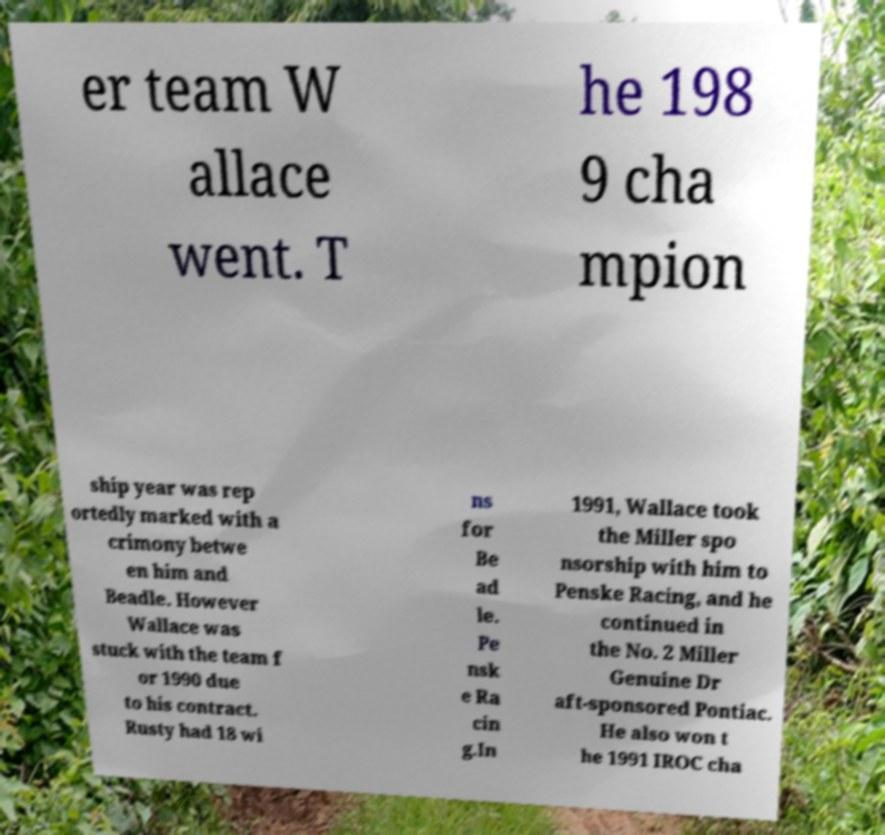Please identify and transcribe the text found in this image. er team W allace went. T he 198 9 cha mpion ship year was rep ortedly marked with a crimony betwe en him and Beadle. However Wallace was stuck with the team f or 1990 due to his contract. Rusty had 18 wi ns for Be ad le. Pe nsk e Ra cin g.In 1991, Wallace took the Miller spo nsorship with him to Penske Racing, and he continued in the No. 2 Miller Genuine Dr aft-sponsored Pontiac. He also won t he 1991 IROC cha 